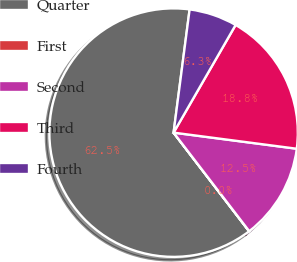<chart> <loc_0><loc_0><loc_500><loc_500><pie_chart><fcel>Quarter<fcel>First<fcel>Second<fcel>Third<fcel>Fourth<nl><fcel>62.46%<fcel>0.02%<fcel>12.51%<fcel>18.75%<fcel>6.26%<nl></chart> 